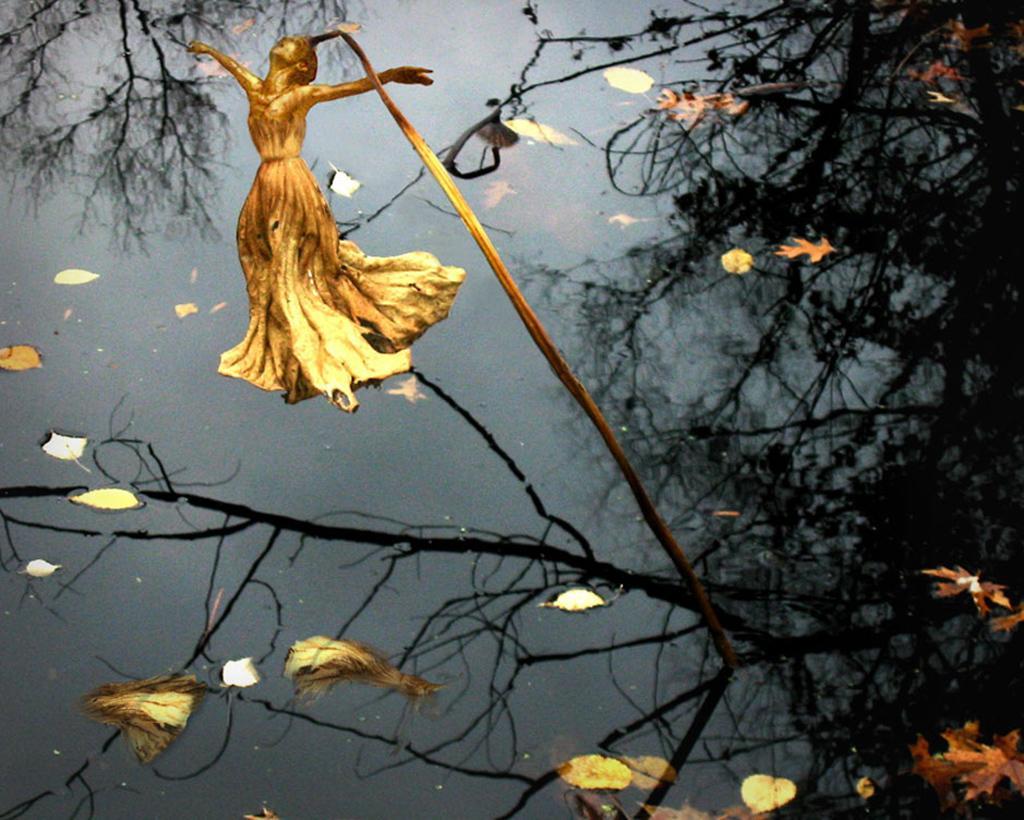How would you summarize this image in a sentence or two? In this image I can see the water, few leaves on the surface of the water and a yellow colored flower which is in the shape of a person to the plant. 